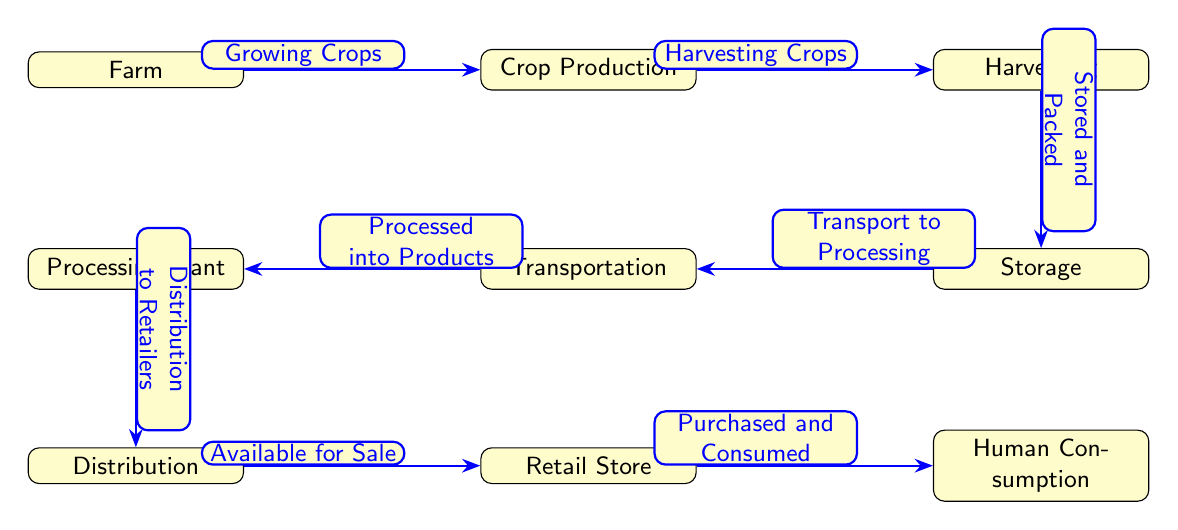What is the first step in the agricultural food chain? The first node in the diagram is labeled 'Farm', indicating that the initial step of the agricultural food chain is taking place on a farm where crops are grown.
Answer: Farm How many nodes are in the diagram? By counting the individual elements that are labeled in the diagram, there are a total of eight nodes representing different stages in the agricultural food chain.
Answer: 8 What happens after crop production? The diagram shows that after 'Crop Production', the next step is 'Harvesting', indicating that crops are gathered after they are produced.
Answer: Harvesting Which node comes after processing? The node that follows 'Processing Plant' in the flow is 'Distribution', which suggests that products are then distributed to retailers after processing.
Answer: Distribution How is transportation categorized in the chain? The diagram indicates that 'Transportation' involves the movement of stored and packed products to processing facilities after they have been harvested.
Answer: Transport to Processing What is the final outcome in the food chain? The last node in the diagram is labeled 'Human Consumption', indicating that the ultimate goal of the food chain is for the products to be consumed by people.
Answer: Human Consumption What is required for the 'Harvesting' to occur? The diagram shows that 'Harvesting Crops' can only happen after 'Crop Production', emphasizing that crops need to be grown before they can be harvested.
Answer: Harvesting Crops Which stage is directly before retail? The stage directly preceding 'Retail Store' is 'Distribution', which indicates that goods are distributed to retail stores before being available for purchase.
Answer: Distribution What type of products are created in the processing stage? According to the flow, the processing stage refers to products as 'Processed into Products', highlighting that the output of the processing stage is various food products.
Answer: Processed into Products 